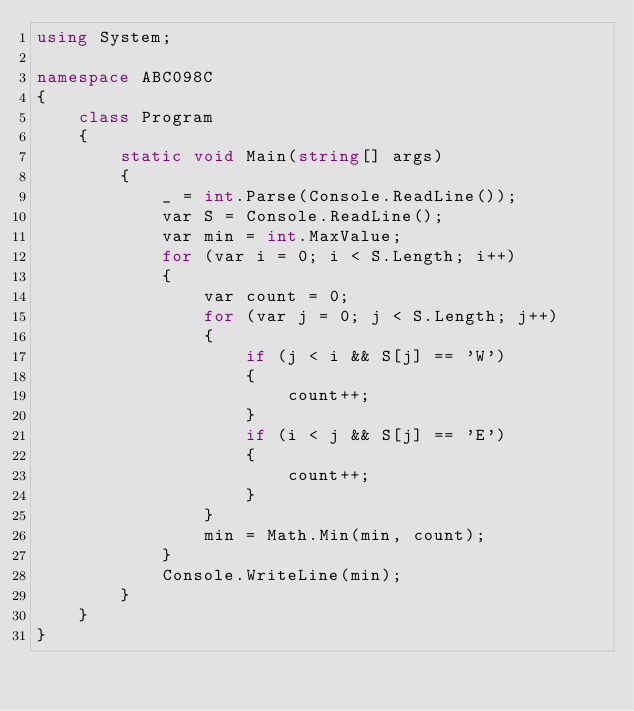<code> <loc_0><loc_0><loc_500><loc_500><_C#_>using System;

namespace ABC098C
{
    class Program
    {
        static void Main(string[] args)
        {
            _ = int.Parse(Console.ReadLine());
            var S = Console.ReadLine();
            var min = int.MaxValue;
            for (var i = 0; i < S.Length; i++)
            {
                var count = 0;
                for (var j = 0; j < S.Length; j++)
                {
                    if (j < i && S[j] == 'W')
                    {
                        count++;
                    }
                    if (i < j && S[j] == 'E')
                    {
                        count++;
                    }
                }
                min = Math.Min(min, count);
            }
            Console.WriteLine(min);
        }
    }
}
</code> 